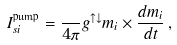Convert formula to latex. <formula><loc_0><loc_0><loc_500><loc_500>I _ { s i } ^ { \text {pump} } = \frac { } { 4 \pi } g ^ { \uparrow \downarrow } m _ { i } \times \frac { d m _ { i } } { d t } \, ,</formula> 